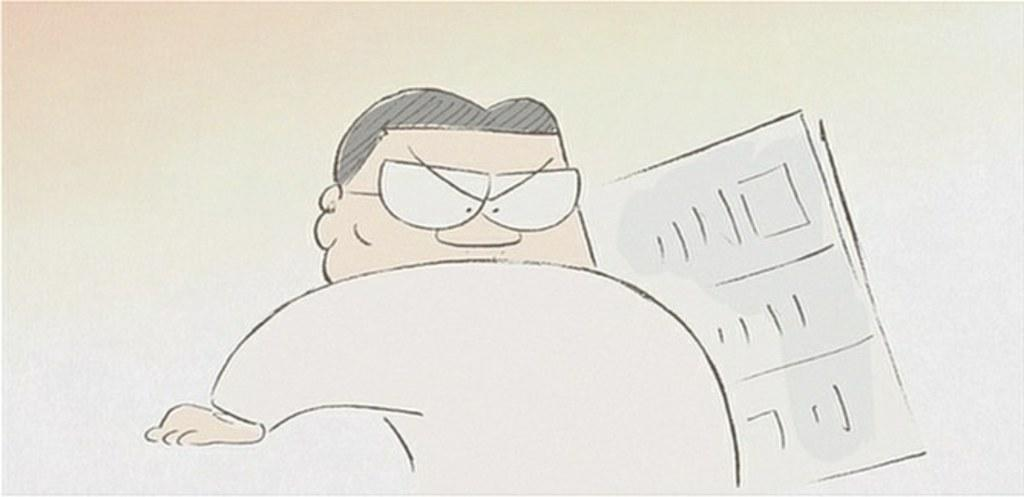What is depicted in the image? There is a drawing of a man in the image. Can you describe the drawing further? There is an object in the drawing. What type of business is being conducted in the drawing? There is no indication of any business being conducted in the drawing, as it only depicts a man and an object. 